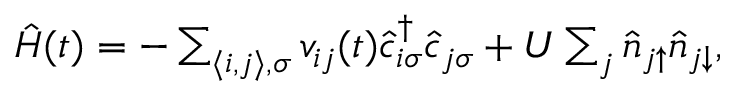Convert formula to latex. <formula><loc_0><loc_0><loc_500><loc_500>\begin{array} { r } { \hat { H } ( t ) = - \sum _ { \langle i , j \rangle , \sigma } v _ { i j } ( t ) \hat { c } _ { i \sigma } ^ { \dagger } \hat { c } _ { j \sigma } + U \sum _ { j } \hat { n } _ { j \uparrow } \hat { n } _ { j \downarrow } , } \end{array}</formula> 